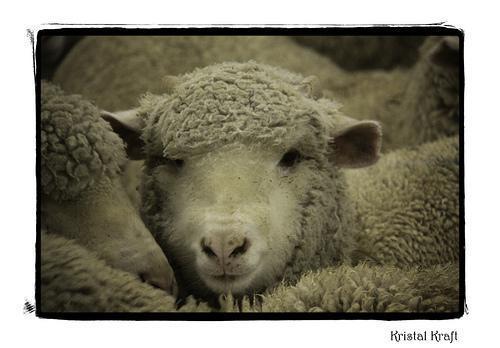How many sheep can you see?
Give a very brief answer. 4. How many benches are there?
Give a very brief answer. 0. 